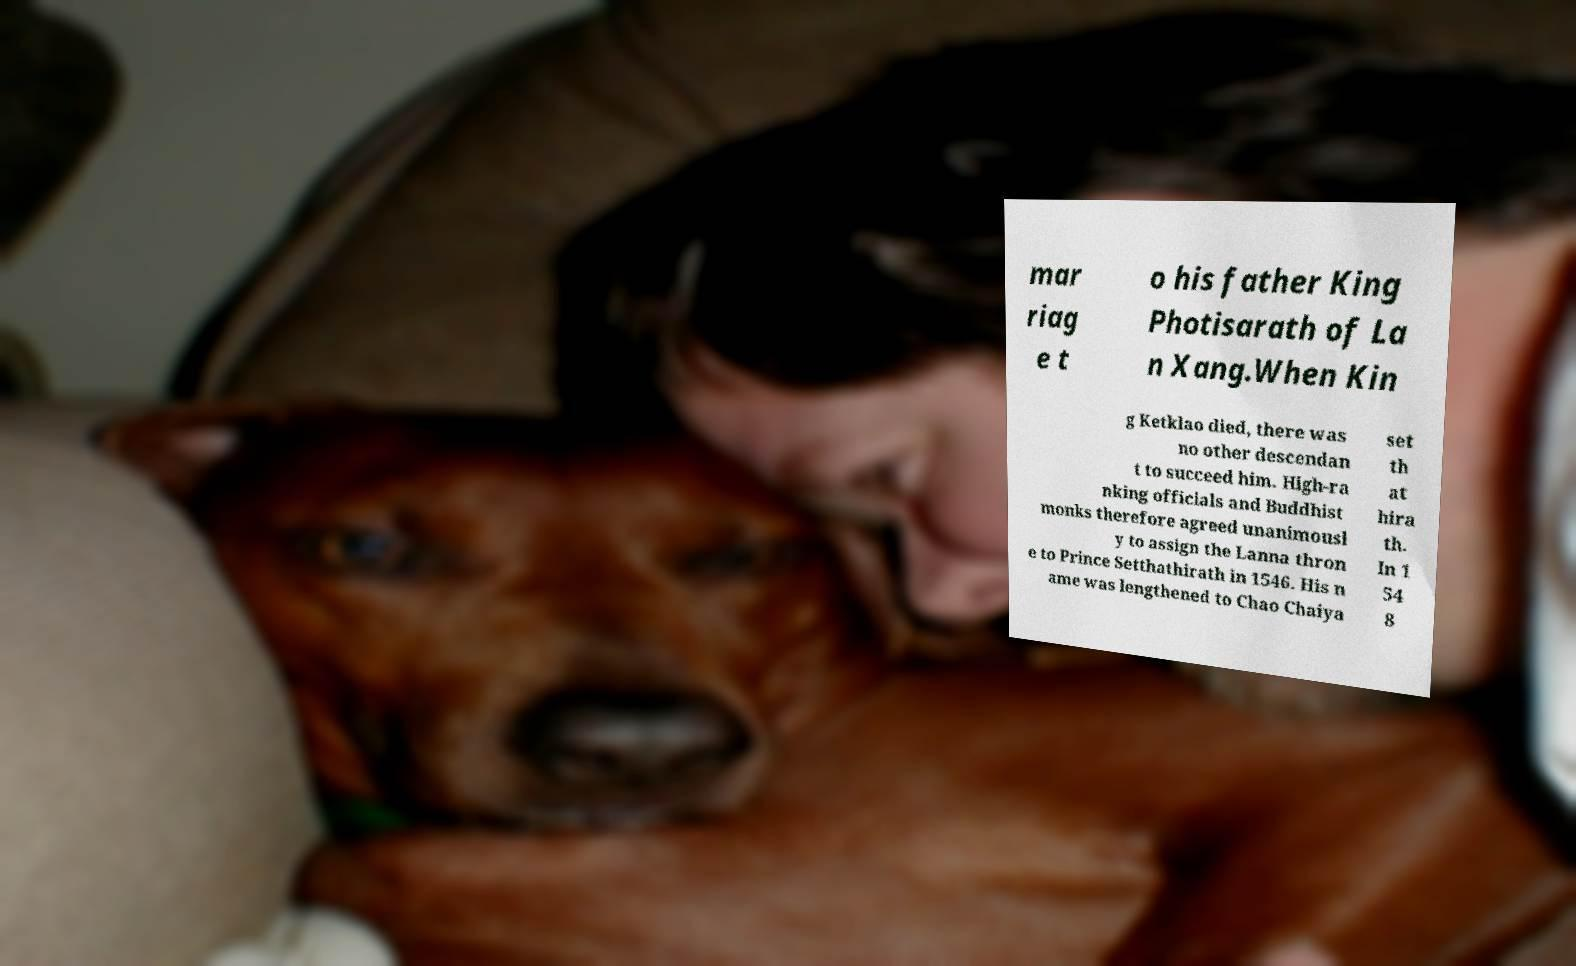Could you extract and type out the text from this image? mar riag e t o his father King Photisarath of La n Xang.When Kin g Ketklao died, there was no other descendan t to succeed him. High-ra nking officials and Buddhist monks therefore agreed unanimousl y to assign the Lanna thron e to Prince Setthathirath in 1546. His n ame was lengthened to Chao Chaiya set th at hira th. In 1 54 8 